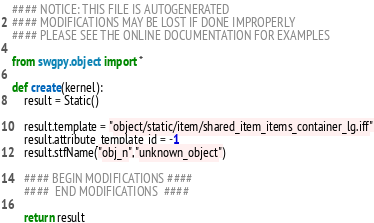Convert code to text. <code><loc_0><loc_0><loc_500><loc_500><_Python_>#### NOTICE: THIS FILE IS AUTOGENERATED
#### MODIFICATIONS MAY BE LOST IF DONE IMPROPERLY
#### PLEASE SEE THE ONLINE DOCUMENTATION FOR EXAMPLES

from swgpy.object import *	

def create(kernel):
	result = Static()

	result.template = "object/static/item/shared_item_items_container_lg.iff"
	result.attribute_template_id = -1
	result.stfName("obj_n","unknown_object")		
	
	#### BEGIN MODIFICATIONS ####
	####  END MODIFICATIONS  ####
	
	return result</code> 